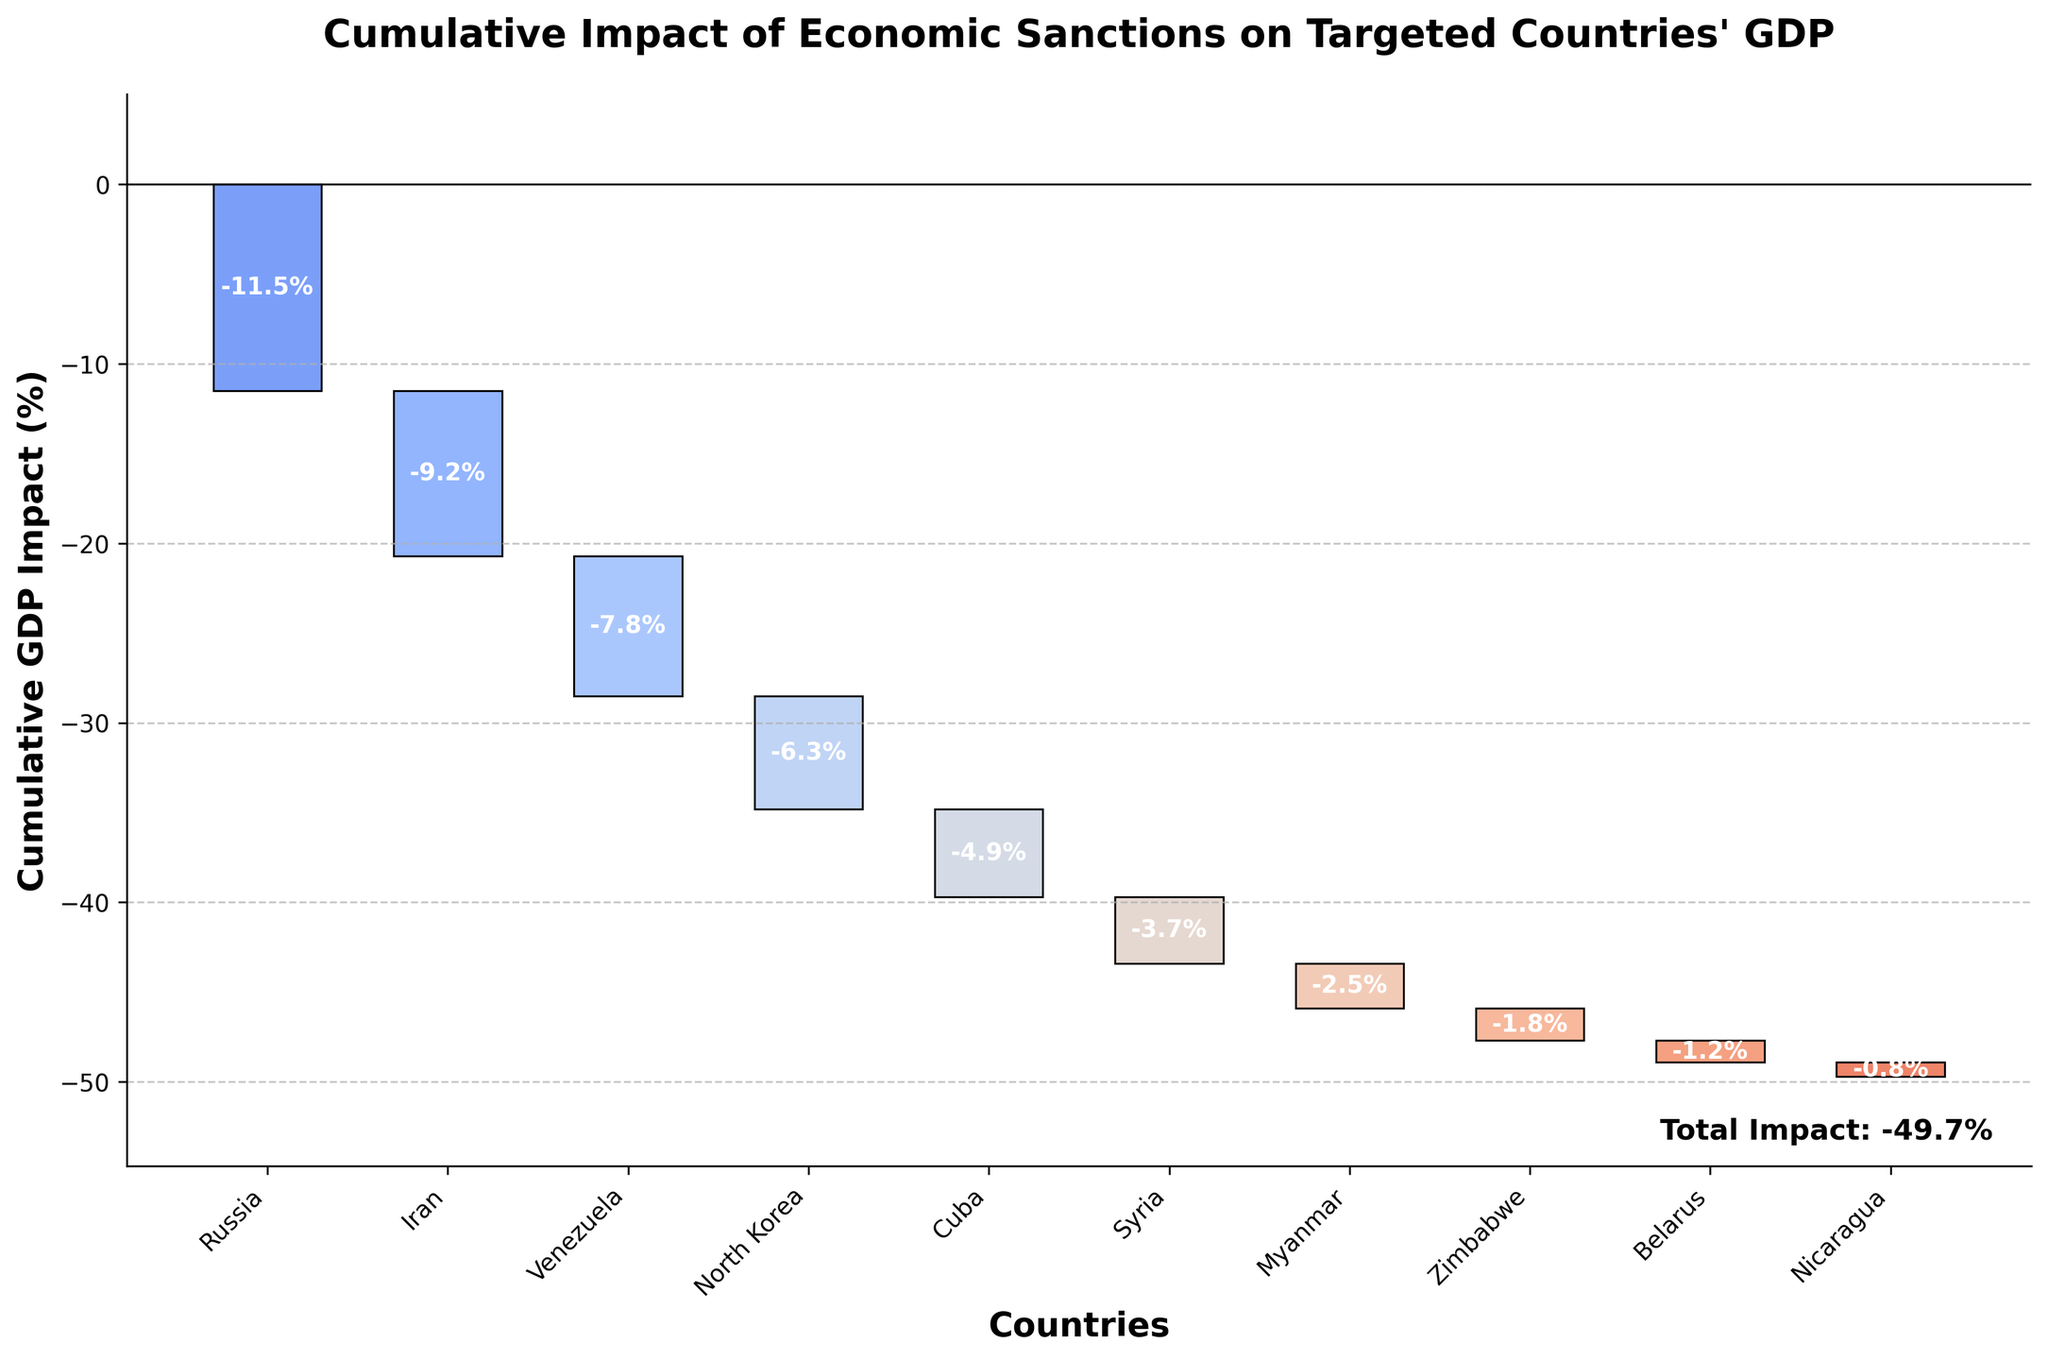What's the title of the figure? The title is written at the top of the figure, stating the main topic of the chart.
Answer: Cumulative Impact of Economic Sanctions on Targeted Countries' GDP Which country has the highest single GDP impact due to economic sanctions? By looking at the heights of the individual bars in the figure, Russia has the highest single GDP impact.
Answer: Russia What's the total cumulative GDP impact shown in the chart? The total cumulative percentage is provided at the end of the figure, often marked or labeled distinctly.
Answer: -49.7% Which countries have a GDP impact greater than 5%? By visually inspecting the heights of the bars, countries with a GDP impact greater than 5% can be identified from the chart.
Answer: Russia, Iran, Venezuela, North Korea What is the sum of the GDP impacts for Venezuela and Cuba? To find this, add the GDP impacts of Venezuela (-7.8%) and Cuba (-4.9%).
Answer: -12.7% What's the difference in GDP impact between Iran and North Korea? Subtract the GDP impact of North Korea (-6.3%) from Iran (-9.2%).
Answer: -2.9% How much greater is the GDP impact on Iran than on Myanmar? The GDP impact on Iran is -9.2% and on Myanmar is -2.5%. Subtract these values to find the difference.
Answer: -6.7% Which two countries experience the least negative GDP impact? By examining the smallest bars, the two countries with the least negative GDP impact can be identified.
Answer: Nicaragua and Belarus What is the cumulative GDP impact after adding the sanctions on North Korea? Sum the GDP impacts of Russia, Iran, Venezuela, and North Korea together. This is illustrated in the cumulative section of the chart.
Answer: -34.8% By how much does the GDP impact of Zimbabwe compare to that of Syria? Compare the GDP impacts of Zimbabwe (-1.8%) and Syria (-3.7%) by subtracting Zimbabwe’s impact from Syria's impact.
Answer: -1.9% 